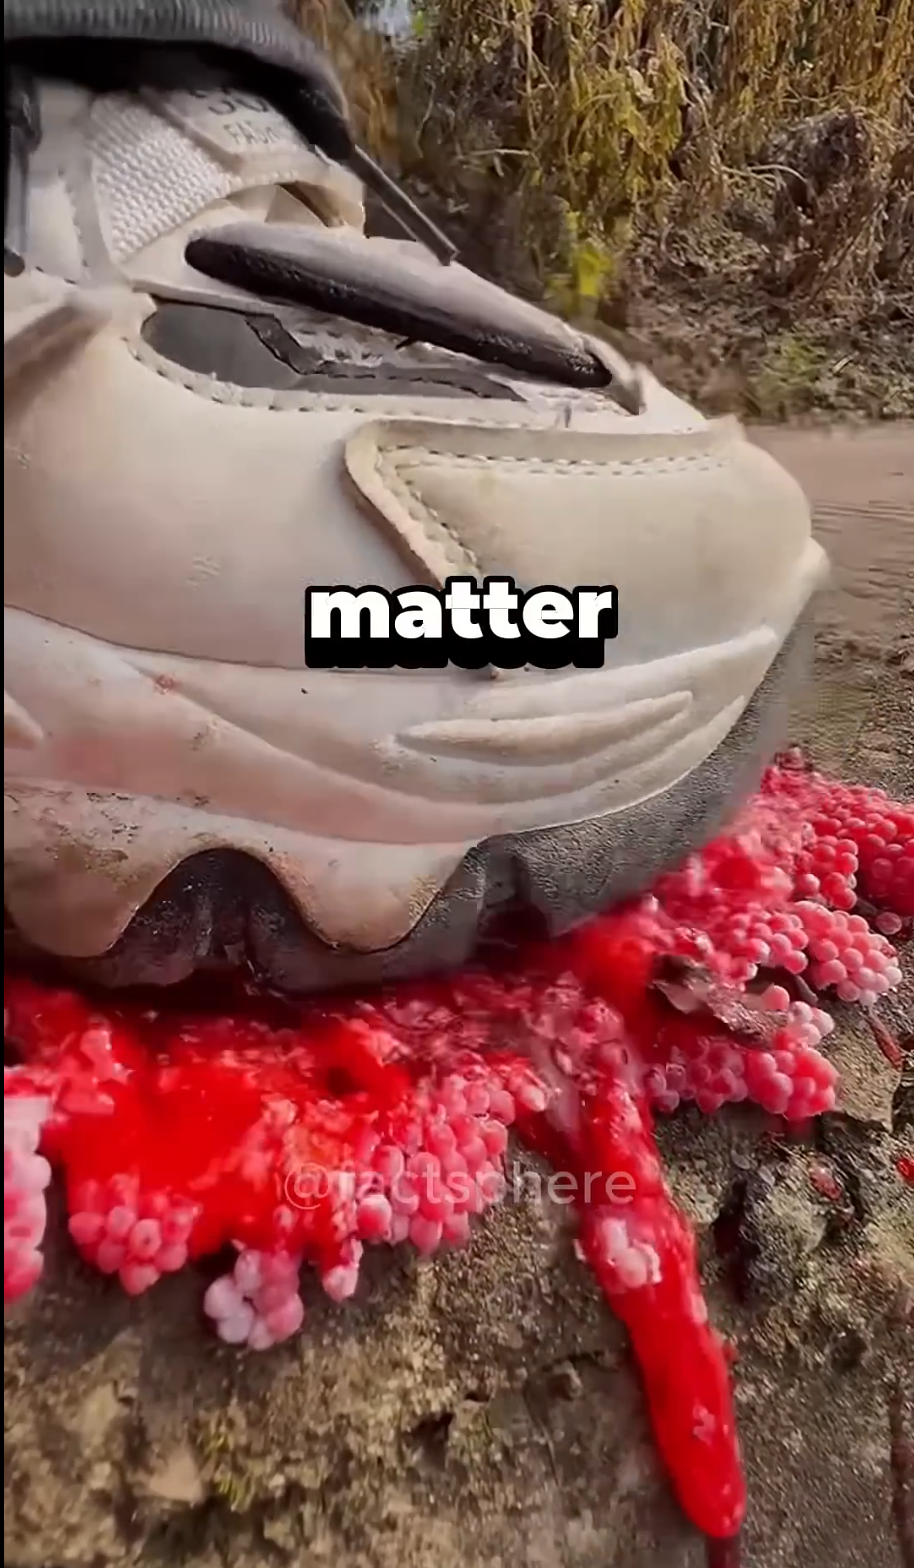Authorities advise citizens to destroy the eggs of the invasive apple snail. In this image, what has happened to the eggs of the invasive apple snail?  The eggs of the invasive apple snail have been crushed. 